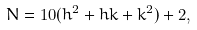<formula> <loc_0><loc_0><loc_500><loc_500>N = 1 0 ( h ^ { 2 } + h k + k ^ { 2 } ) + 2 ,</formula> 